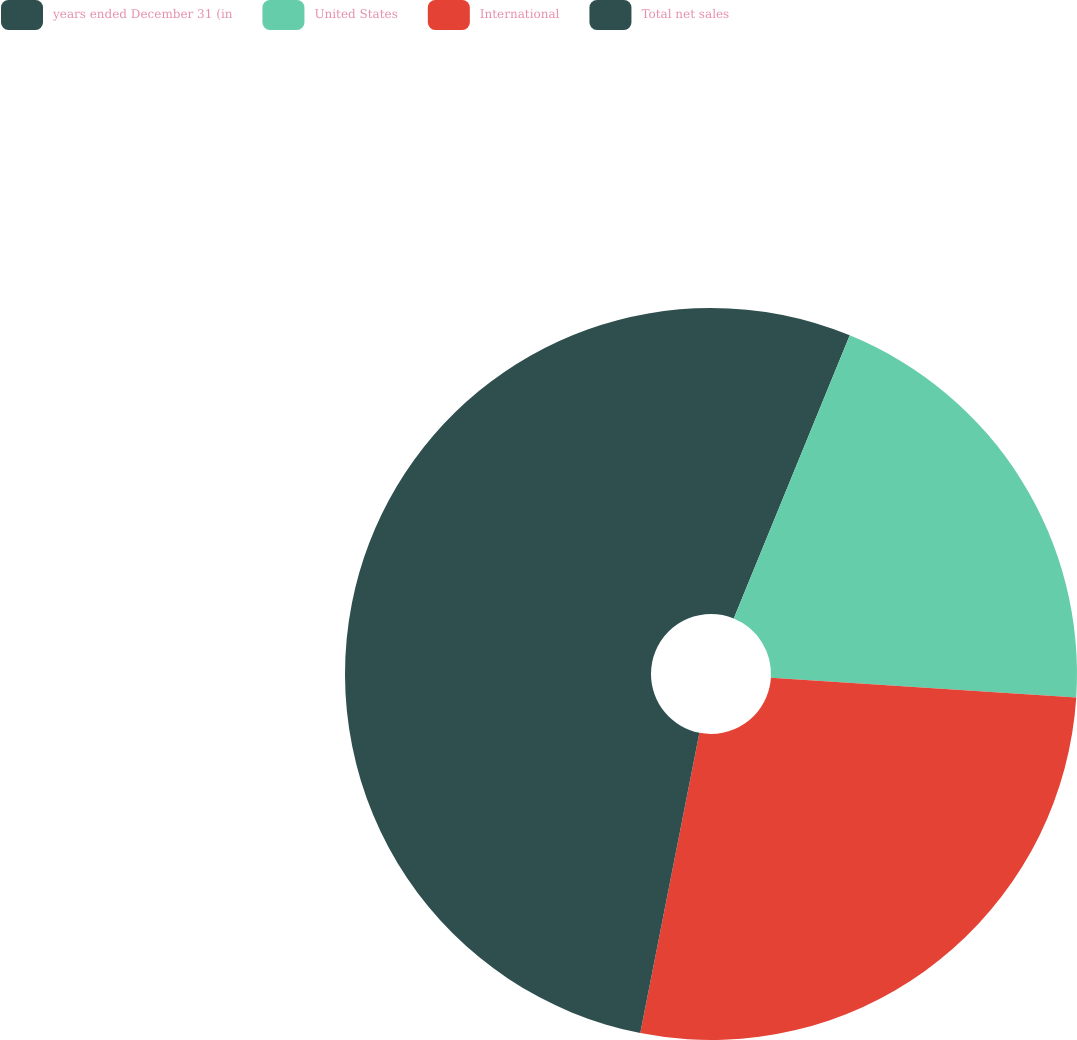Convert chart to OTSL. <chart><loc_0><loc_0><loc_500><loc_500><pie_chart><fcel>years ended December 31 (in<fcel>United States<fcel>International<fcel>Total net sales<nl><fcel>6.19%<fcel>19.83%<fcel>27.08%<fcel>46.91%<nl></chart> 